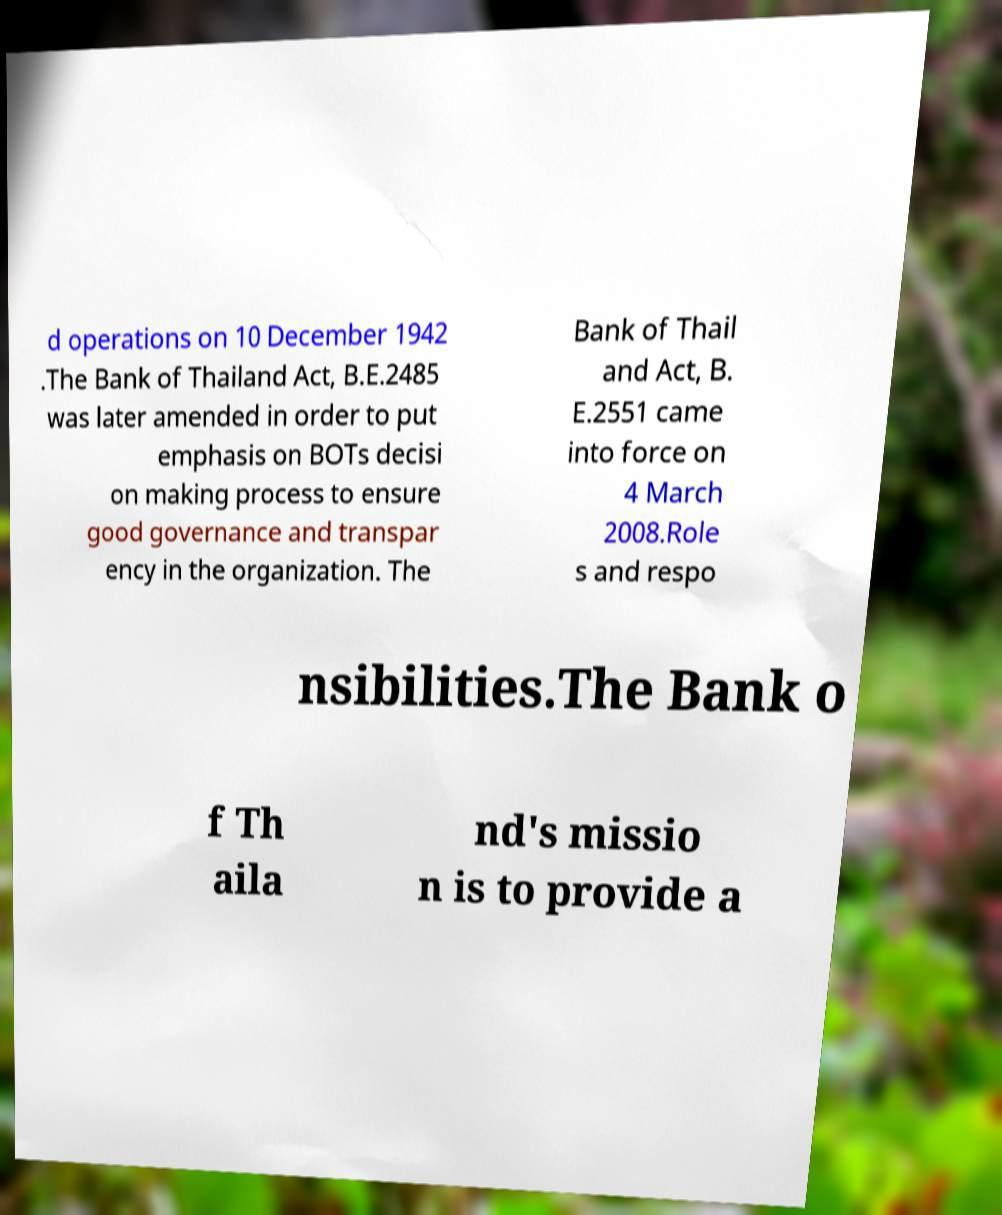Could you extract and type out the text from this image? d operations on 10 December 1942 .The Bank of Thailand Act, B.E.2485 was later amended in order to put emphasis on BOTs decisi on making process to ensure good governance and transpar ency in the organization. The Bank of Thail and Act, B. E.2551 came into force on 4 March 2008.Role s and respo nsibilities.The Bank o f Th aila nd's missio n is to provide a 